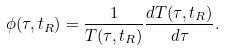Convert formula to latex. <formula><loc_0><loc_0><loc_500><loc_500>\phi ( \tau , t _ { R } ) = \frac { 1 } { T ( \tau , t _ { R } ) } \frac { d T ( \tau , t _ { R } ) } { d \tau } .</formula> 